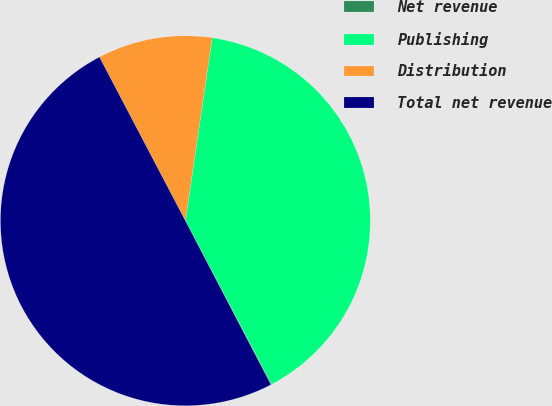<chart> <loc_0><loc_0><loc_500><loc_500><pie_chart><fcel>Net revenue<fcel>Publishing<fcel>Distribution<fcel>Total net revenue<nl><fcel>0.07%<fcel>39.96%<fcel>10.01%<fcel>49.97%<nl></chart> 